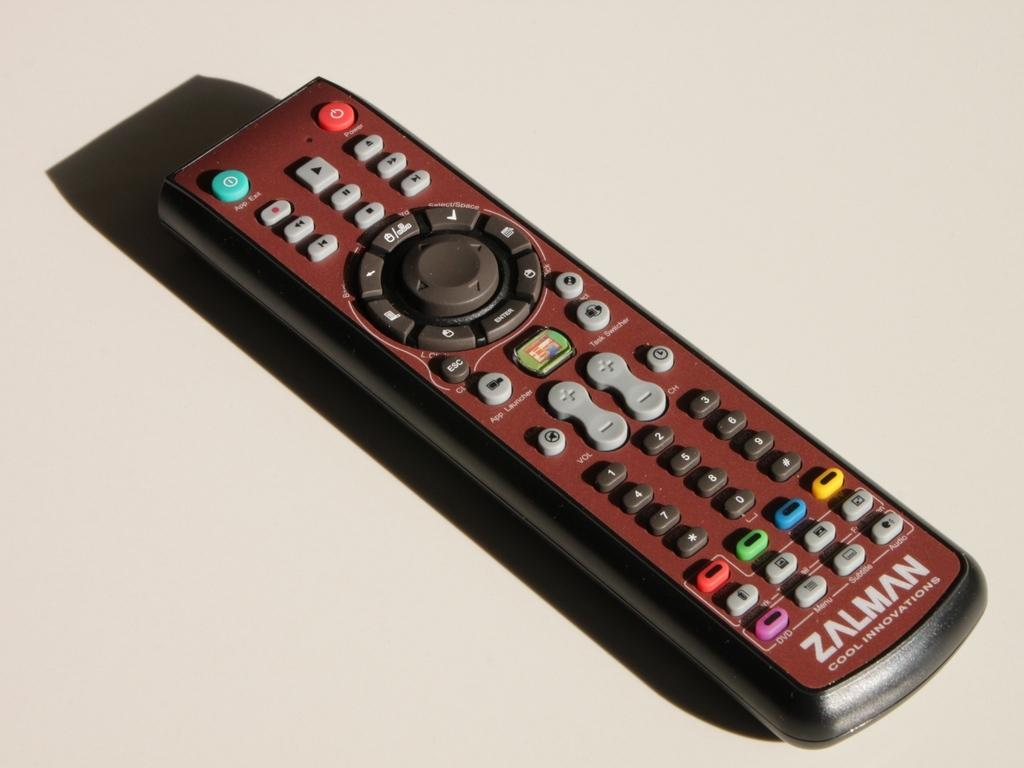<image>
Offer a succinct explanation of the picture presented. The Zalman remote control has a large round button in the middle. 